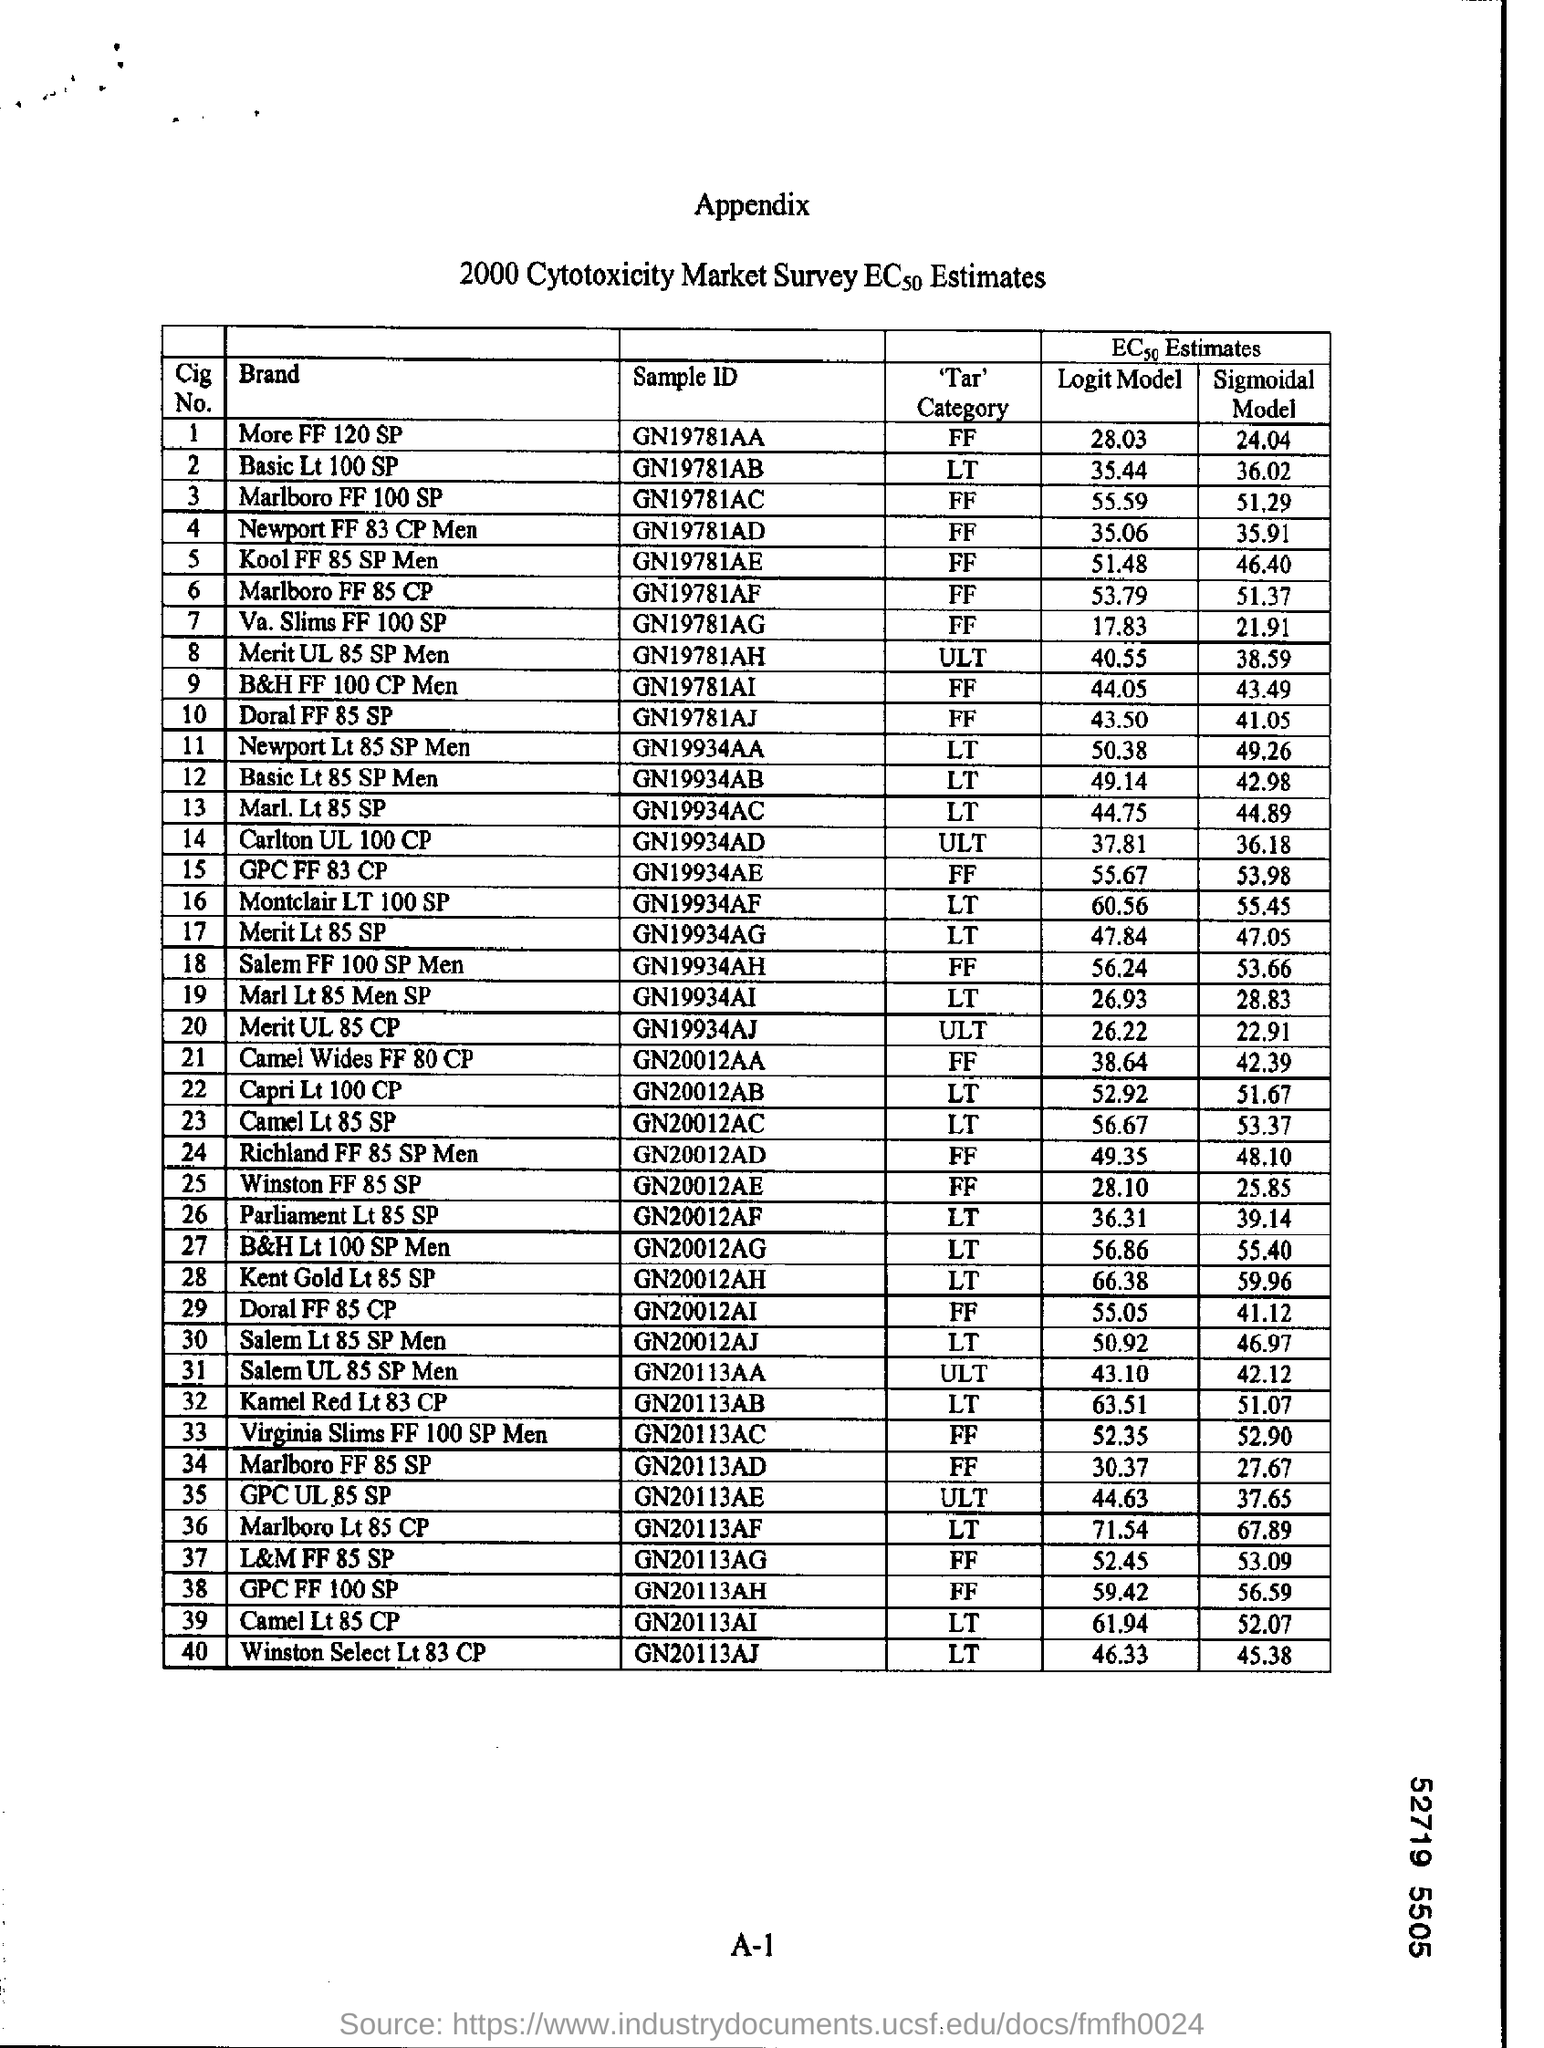What is sample ID of More FF 120 SP?
Provide a succinct answer. GN19781AA. What is Sample ID of Basic Lt 100 SP?
Give a very brief answer. GN19781AB. 